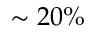Convert formula to latex. <formula><loc_0><loc_0><loc_500><loc_500>\sim 2 0 \%</formula> 